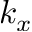<formula> <loc_0><loc_0><loc_500><loc_500>k _ { x }</formula> 